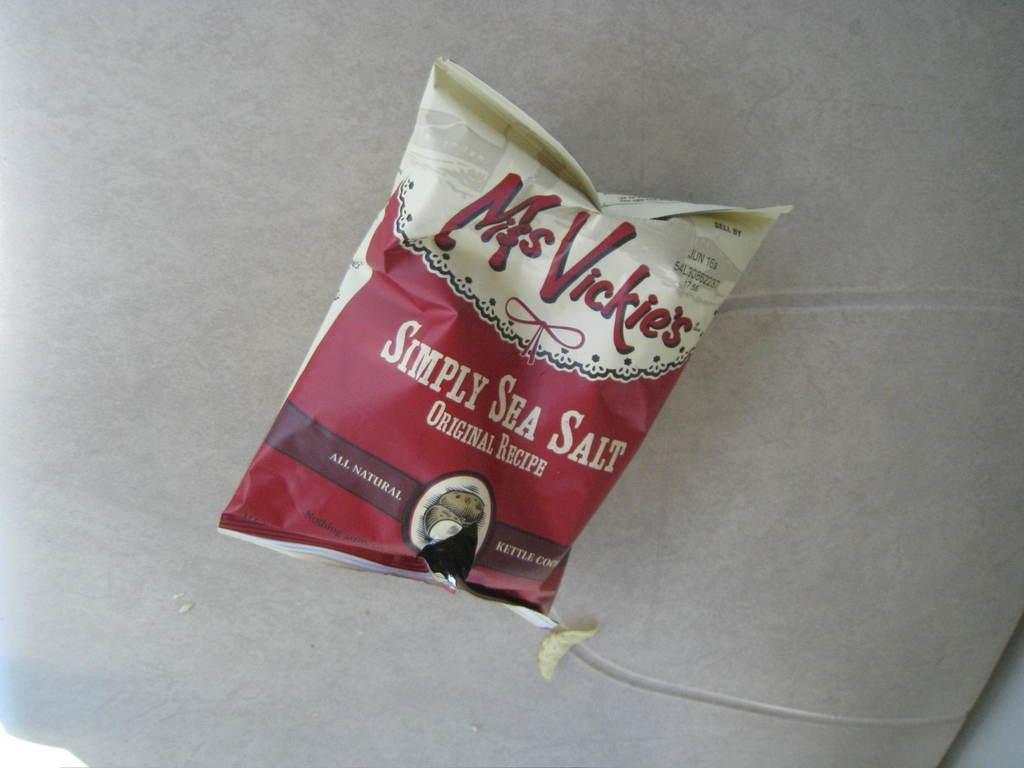What is the main object in the image? There is a chips packet in the image. What type of wire can be seen connecting the chips packet to the thunder in the image? There is no wire, chips packet, or thunder present in the image. 